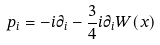Convert formula to latex. <formula><loc_0><loc_0><loc_500><loc_500>p _ { i } = - i \partial _ { i } - \frac { 3 } { 4 } i \partial _ { i } W ( x )</formula> 